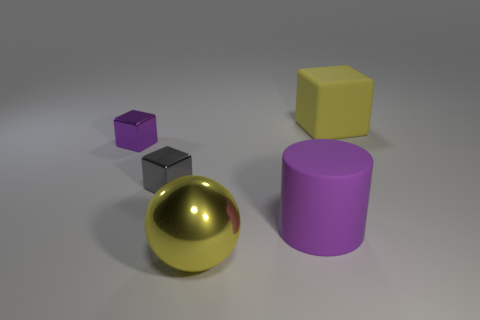The large metal object that is the same color as the large matte cube is what shape?
Ensure brevity in your answer.  Sphere. There is a big rubber thing in front of the cube that is right of the large yellow shiny ball; how many shiny objects are left of it?
Make the answer very short. 3. Is the number of gray objects behind the large yellow metallic ball less than the number of small gray objects that are behind the yellow rubber block?
Ensure brevity in your answer.  No. What color is the other tiny shiny object that is the same shape as the gray shiny thing?
Offer a very short reply. Purple. What size is the gray metallic block?
Your answer should be very brief. Small. How many cyan shiny balls are the same size as the matte cylinder?
Provide a short and direct response. 0. Do the large rubber cube and the large shiny object have the same color?
Your answer should be compact. Yes. Does the large yellow object to the left of the yellow cube have the same material as the block right of the large purple rubber thing?
Your response must be concise. No. Is the number of gray blocks greater than the number of small metal objects?
Give a very brief answer. No. Is there any other thing that is the same color as the ball?
Offer a terse response. Yes. 